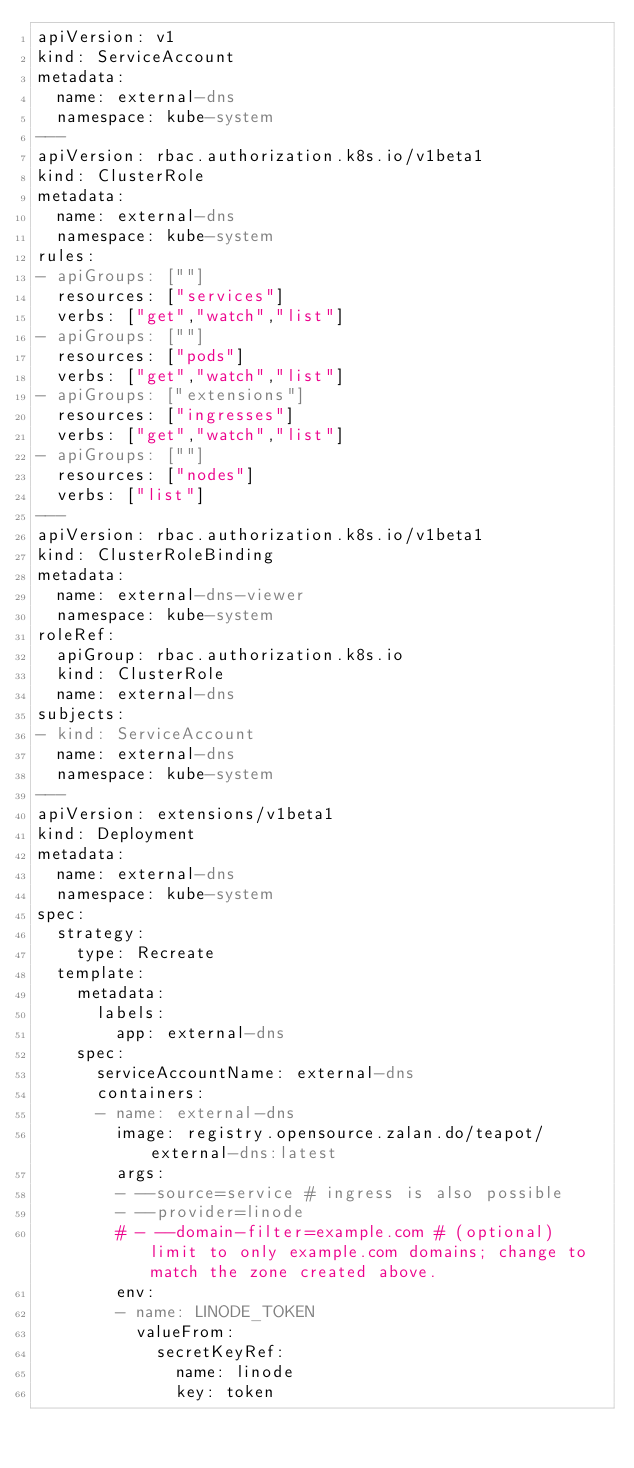Convert code to text. <code><loc_0><loc_0><loc_500><loc_500><_YAML_>apiVersion: v1
kind: ServiceAccount
metadata:
  name: external-dns
  namespace: kube-system
---
apiVersion: rbac.authorization.k8s.io/v1beta1
kind: ClusterRole
metadata:
  name: external-dns
  namespace: kube-system
rules:
- apiGroups: [""]
  resources: ["services"]
  verbs: ["get","watch","list"]
- apiGroups: [""]
  resources: ["pods"]
  verbs: ["get","watch","list"]
- apiGroups: ["extensions"]
  resources: ["ingresses"]
  verbs: ["get","watch","list"]
- apiGroups: [""]
  resources: ["nodes"]
  verbs: ["list"]
---
apiVersion: rbac.authorization.k8s.io/v1beta1
kind: ClusterRoleBinding
metadata:
  name: external-dns-viewer
  namespace: kube-system
roleRef:
  apiGroup: rbac.authorization.k8s.io
  kind: ClusterRole
  name: external-dns
subjects:
- kind: ServiceAccount
  name: external-dns
  namespace: kube-system
---
apiVersion: extensions/v1beta1
kind: Deployment
metadata:
  name: external-dns
  namespace: kube-system
spec:
  strategy:
    type: Recreate
  template:
    metadata:
      labels:
        app: external-dns
    spec:
      serviceAccountName: external-dns
      containers:
      - name: external-dns
        image: registry.opensource.zalan.do/teapot/external-dns:latest
        args:
        - --source=service # ingress is also possible
        - --provider=linode
        # - --domain-filter=example.com # (optional) limit to only example.com domains; change to match the zone created above.
        env:
        - name: LINODE_TOKEN
          valueFrom:
            secretKeyRef:
              name: linode
              key: token
</code> 